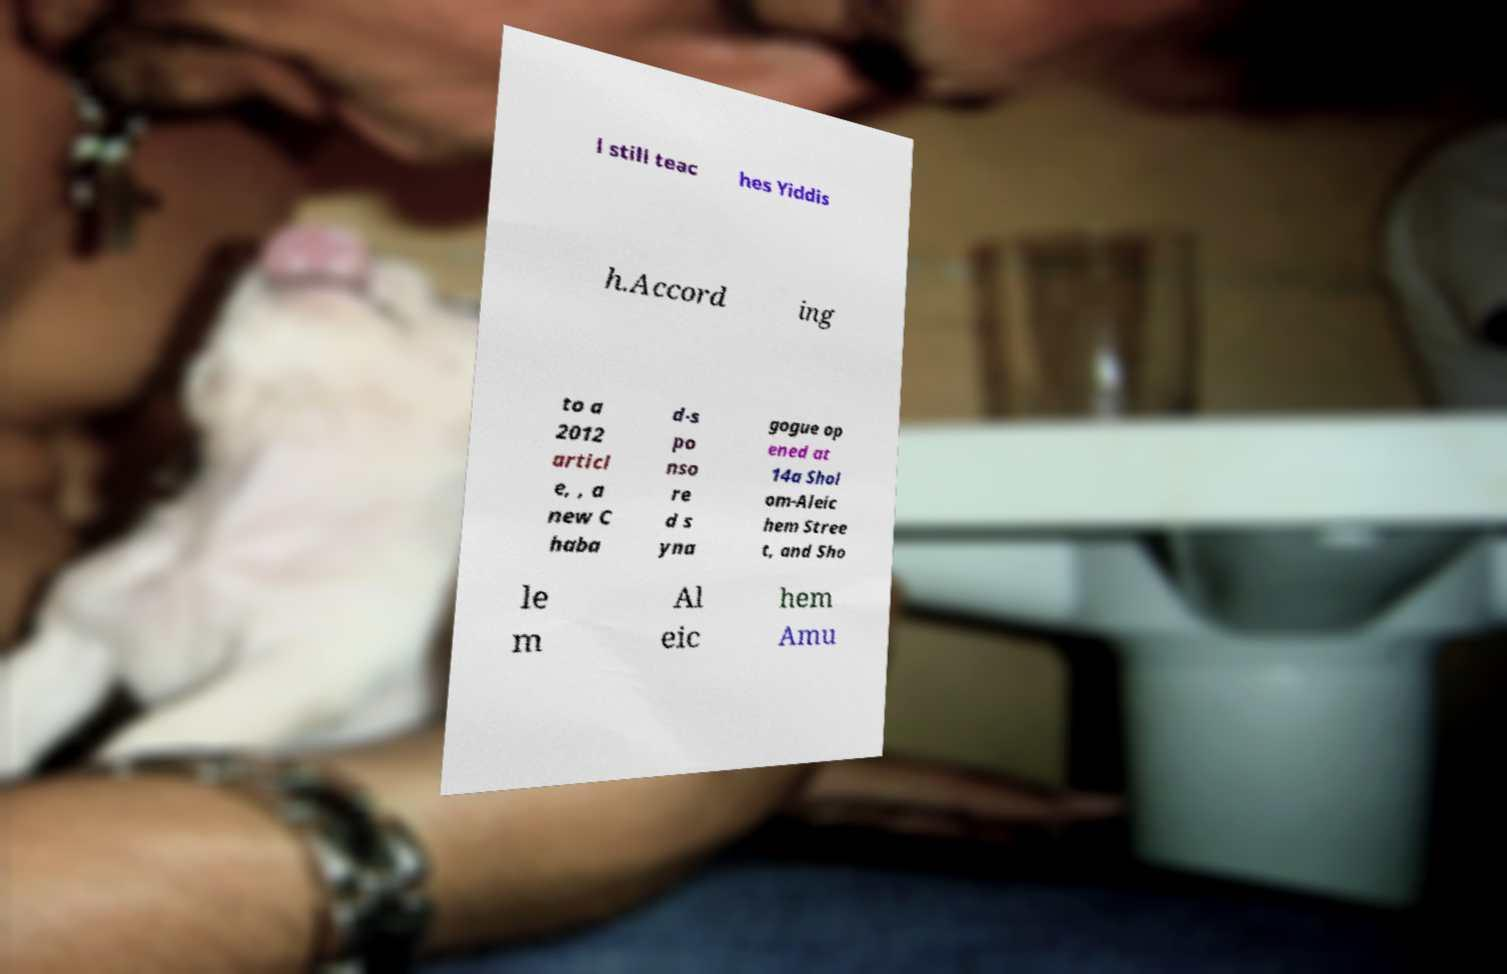Can you accurately transcribe the text from the provided image for me? l still teac hes Yiddis h.Accord ing to a 2012 articl e, , a new C haba d-s po nso re d s yna gogue op ened at 14a Shol om-Aleic hem Stree t, and Sho le m Al eic hem Amu 